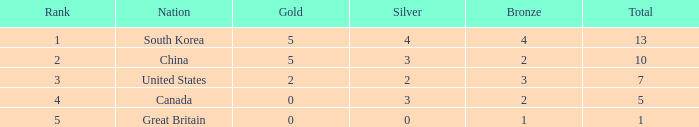What is the overall sum of gold, when silver equals 2, and when the total is under 7? 0.0. 